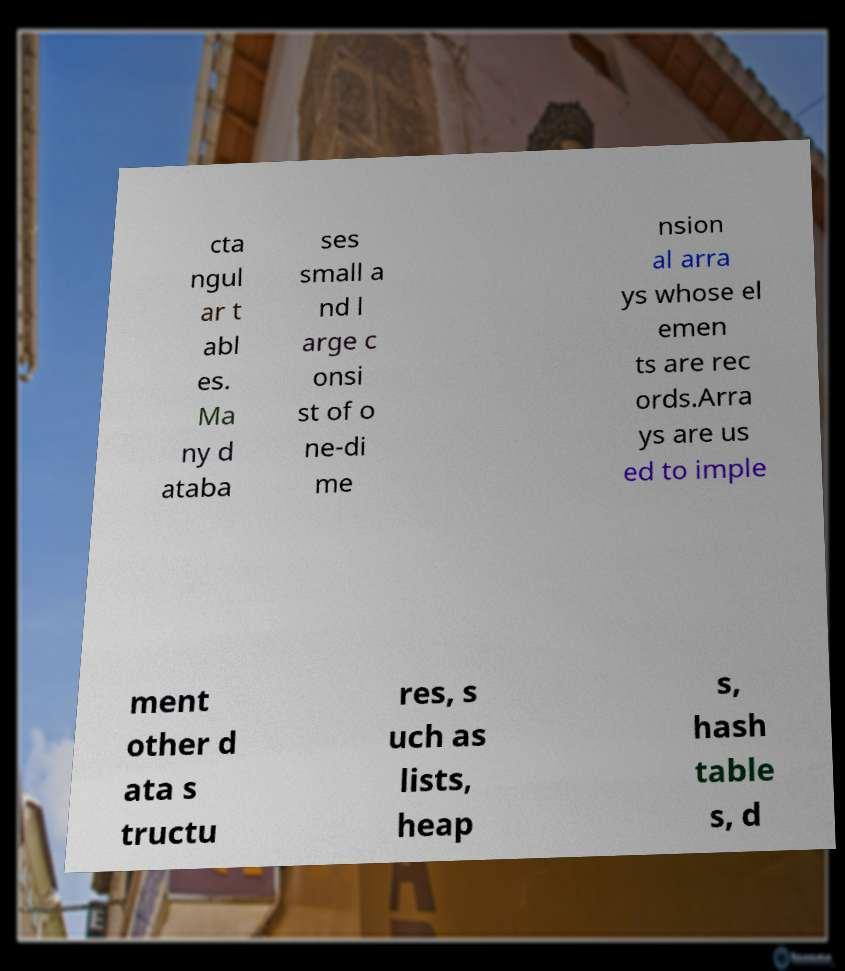Could you assist in decoding the text presented in this image and type it out clearly? cta ngul ar t abl es. Ma ny d ataba ses small a nd l arge c onsi st of o ne-di me nsion al arra ys whose el emen ts are rec ords.Arra ys are us ed to imple ment other d ata s tructu res, s uch as lists, heap s, hash table s, d 